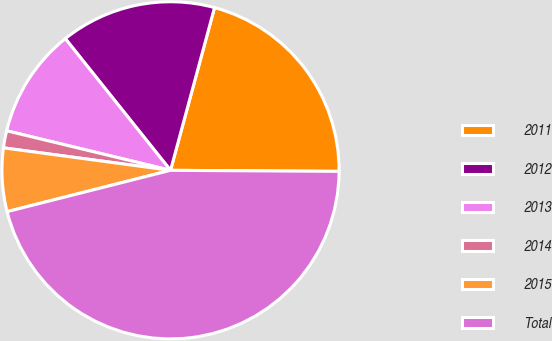Convert chart to OTSL. <chart><loc_0><loc_0><loc_500><loc_500><pie_chart><fcel>2011<fcel>2012<fcel>2013<fcel>2014<fcel>2015<fcel>Total<nl><fcel>20.89%<fcel>14.93%<fcel>10.5%<fcel>1.64%<fcel>6.07%<fcel>45.95%<nl></chart> 